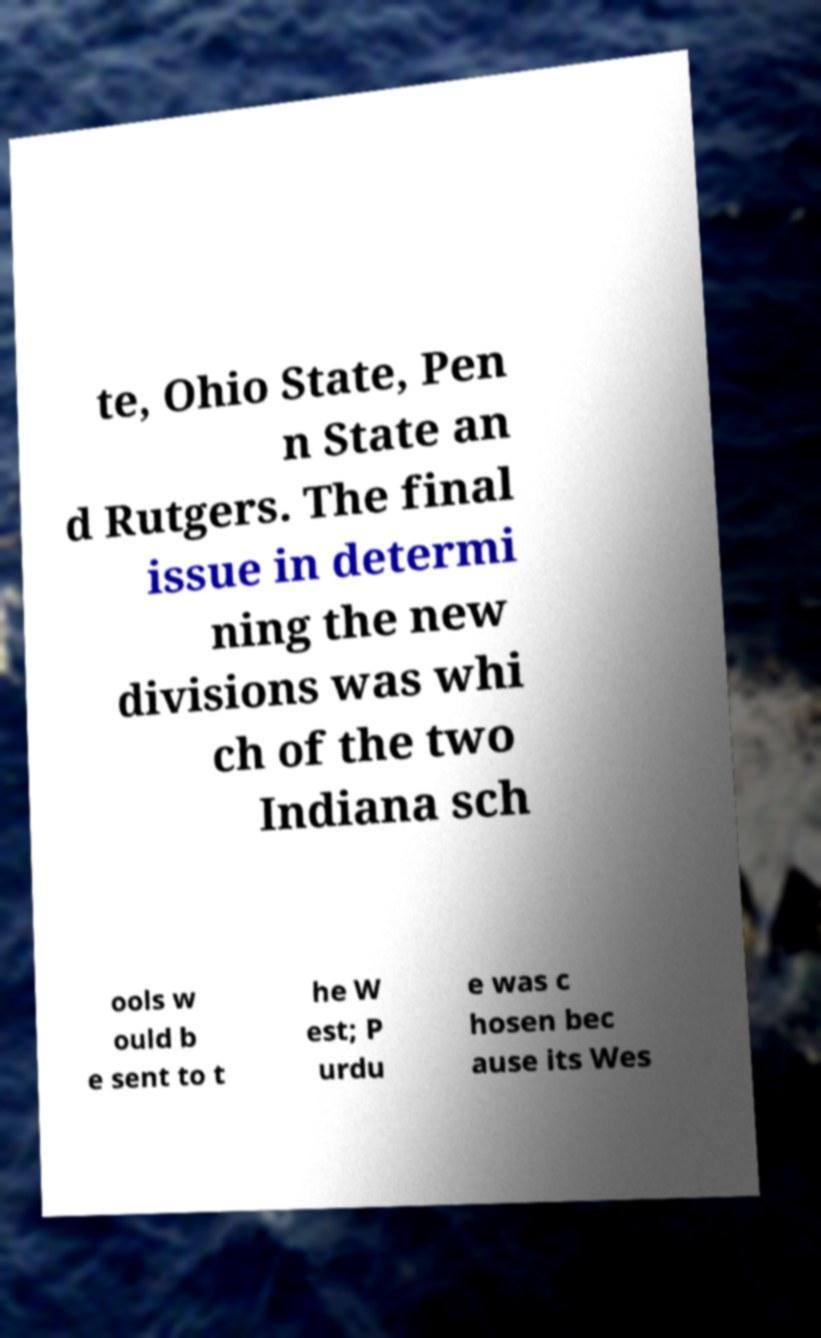I need the written content from this picture converted into text. Can you do that? te, Ohio State, Pen n State an d Rutgers. The final issue in determi ning the new divisions was whi ch of the two Indiana sch ools w ould b e sent to t he W est; P urdu e was c hosen bec ause its Wes 